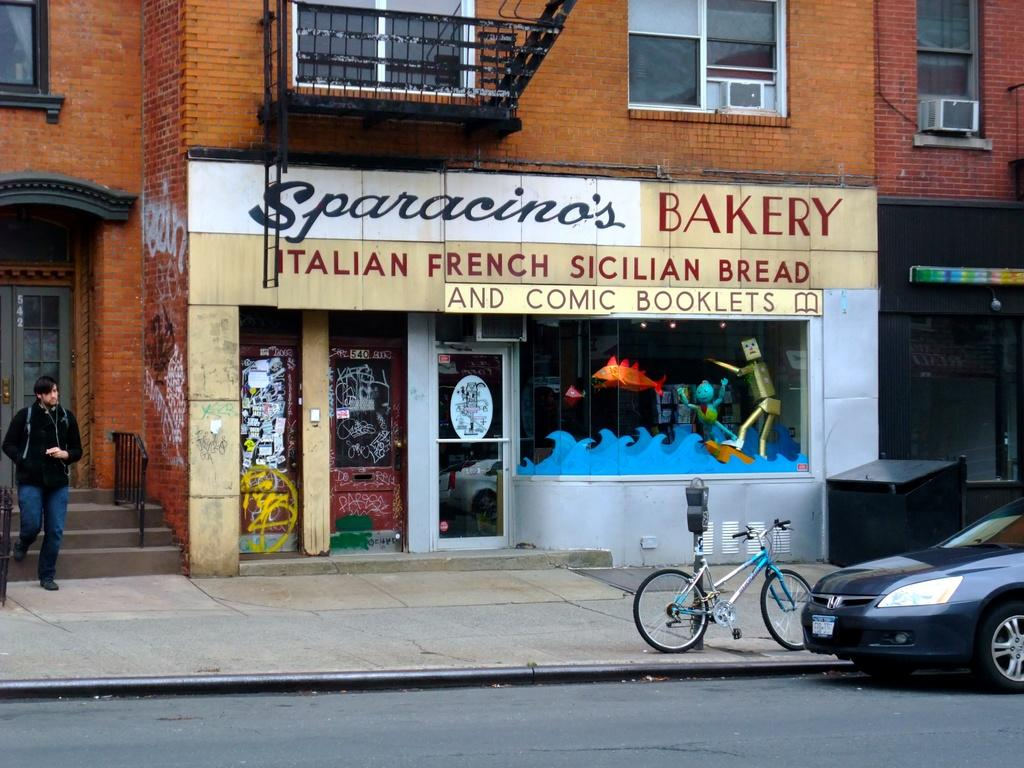What type of vehicle is on the road in the image? There is a car on the road in the image. What other mode of transportation can be seen in the image? There is a bicycle in the image. What object is related to parking in the image? There is a parking meter in the image. Can you describe the person in the image? There is a person standing in the image. What type of establishment is visible in the image? There is a shop in the image. What type of structure is in the background of the image? There is a building in the image. Where is the fireman in the image? There is no fireman present in the image. What type of body is visible in the image? There is no specific body visible in the image; it is a scene featuring a car, bicycle, parking meter, person, shop, and building. 